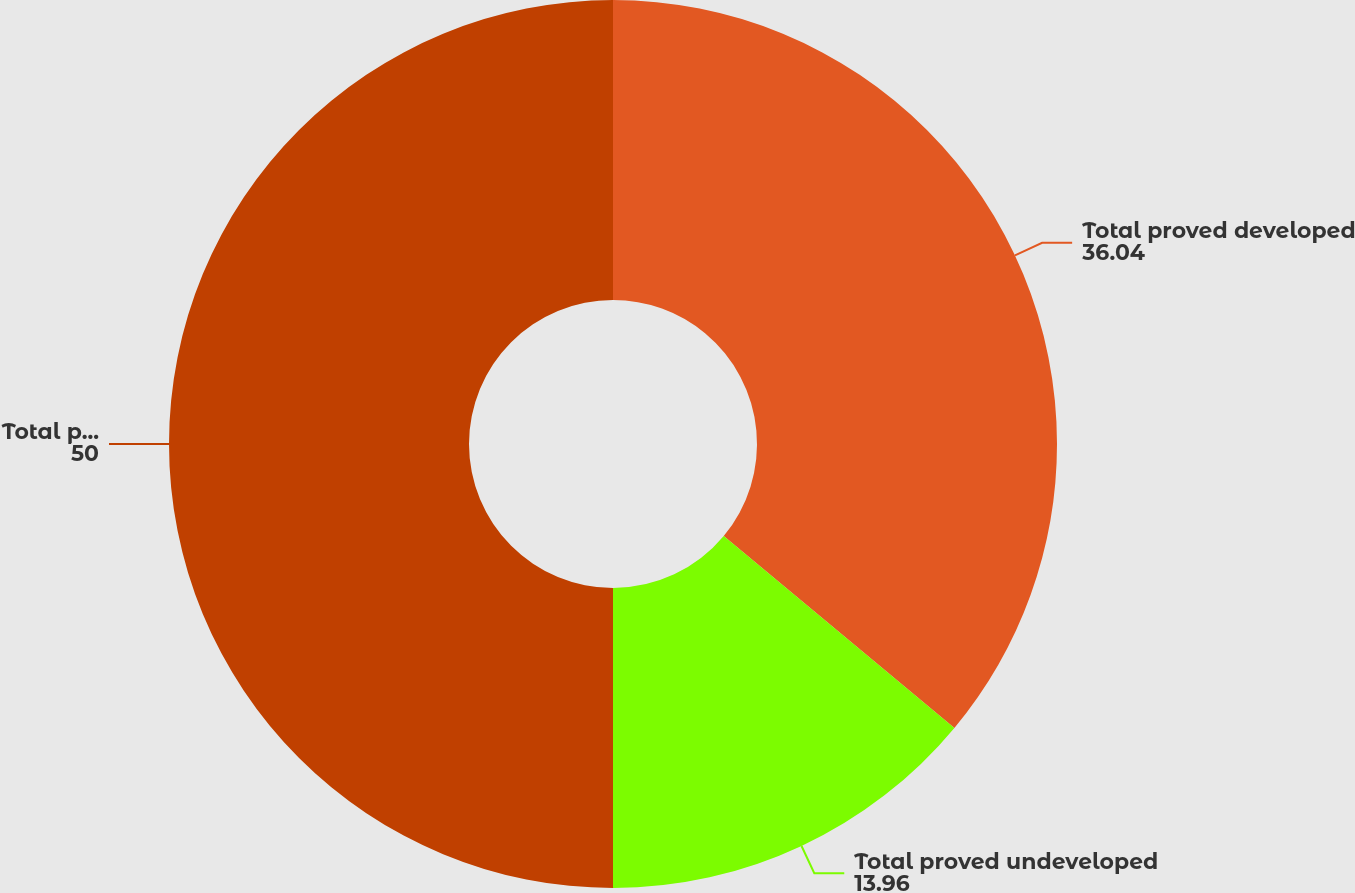<chart> <loc_0><loc_0><loc_500><loc_500><pie_chart><fcel>Total proved developed<fcel>Total proved undeveloped<fcel>Total proved reserves (mmboe)<nl><fcel>36.04%<fcel>13.96%<fcel>50.0%<nl></chart> 